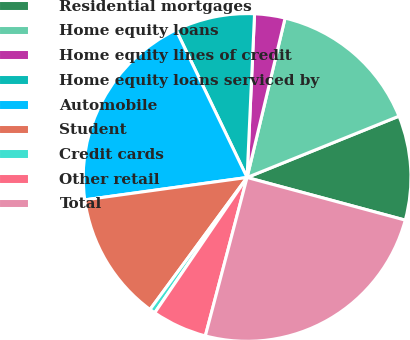<chart> <loc_0><loc_0><loc_500><loc_500><pie_chart><fcel>Residential mortgages<fcel>Home equity loans<fcel>Home equity lines of credit<fcel>Home equity loans serviced by<fcel>Automobile<fcel>Student<fcel>Credit cards<fcel>Other retail<fcel>Total<nl><fcel>10.3%<fcel>15.17%<fcel>3.0%<fcel>7.87%<fcel>20.04%<fcel>12.73%<fcel>0.56%<fcel>5.43%<fcel>24.91%<nl></chart> 